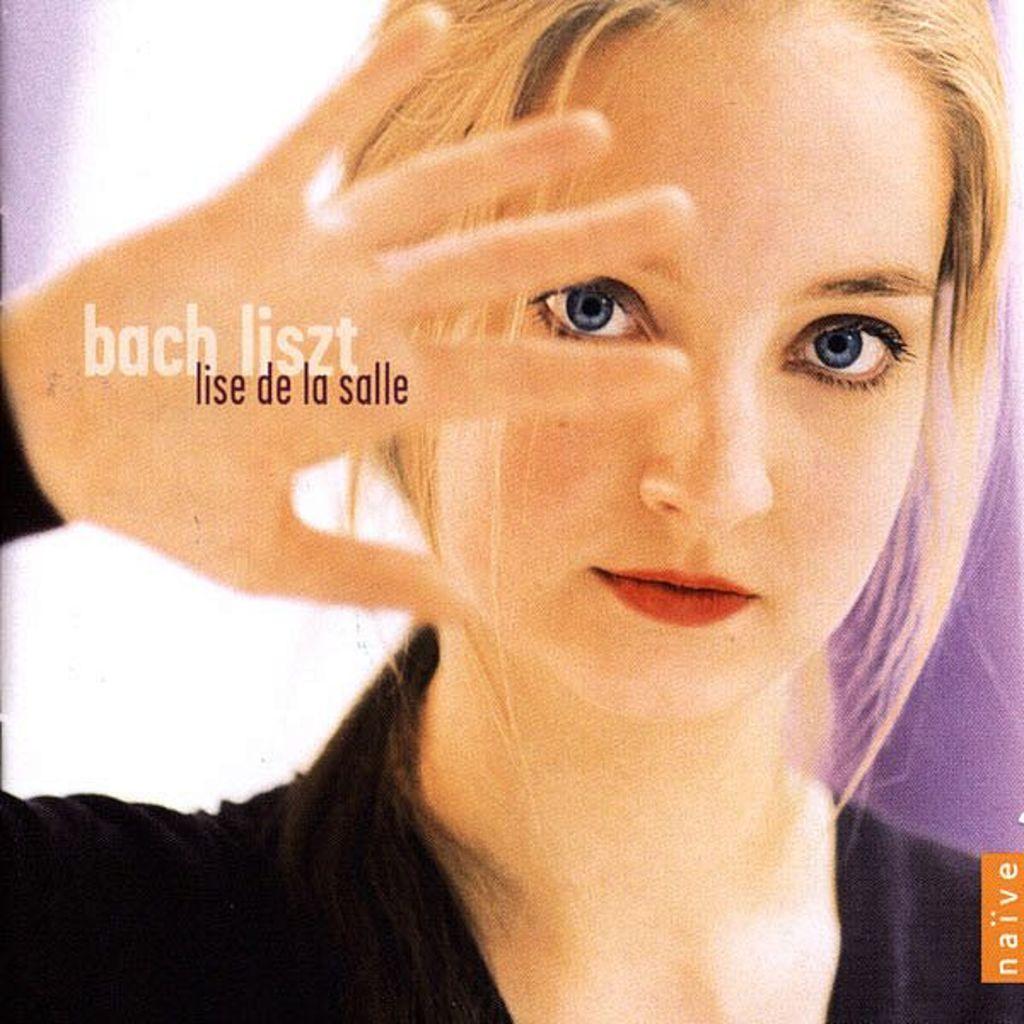How would you summarize this image in a sentence or two? In this picture we can see a girl wore a black dress and on her hand we can see some text. 